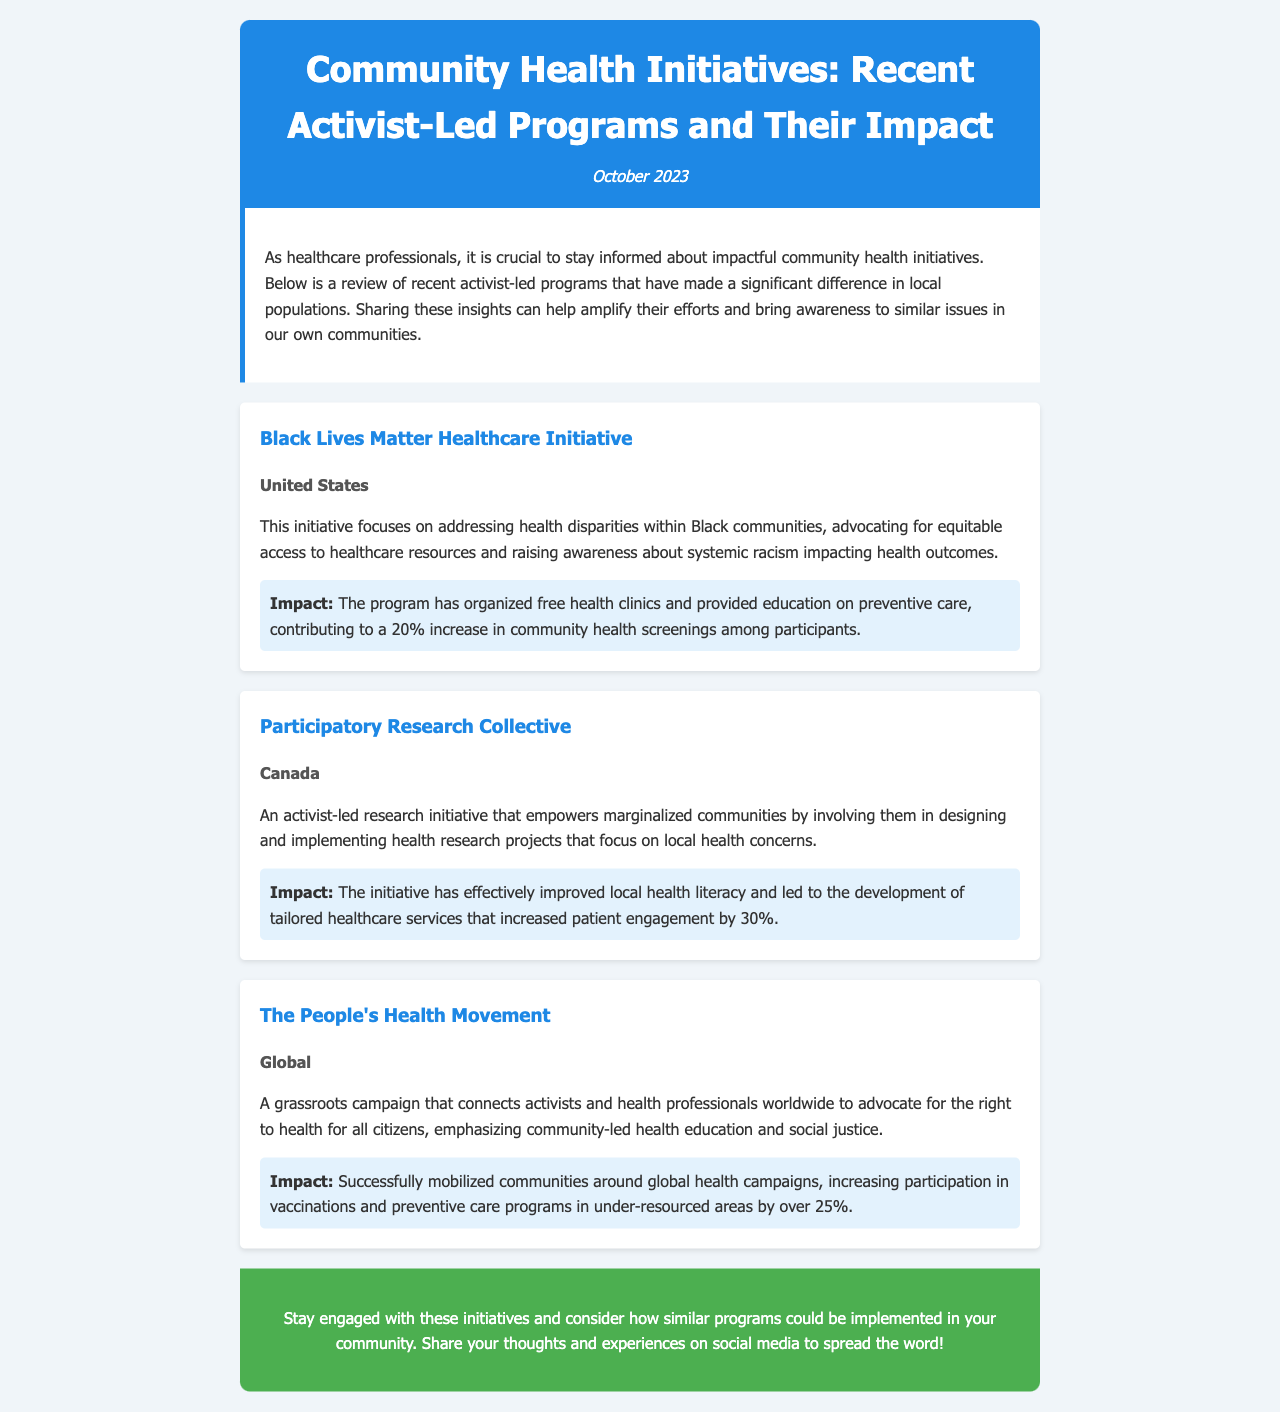what is the title of the newsletter? The title is prominently displayed in the header section of the document.
Answer: Community Health Initiatives: Recent Activist-Led Programs and Their Impact what is the impact percentage of the Black Lives Matter Healthcare Initiative on community health screenings? The initiative's impact on community health screenings is explicitly stated under the impact section.
Answer: 20% which country is the Participatory Research Collective based in? The location of the initiative is mentioned in the program information section.
Answer: Canada what type of movement is The People's Health Movement? The type of movement is described in the introduction of the program segment.
Answer: grassroots how much did patient engagement increase by the Participatory Research Collective? This increase is specifically outlined in the impact description of the program.
Answer: 30% what is the common theme addressed by all the initiatives? The overarching theme is implied throughout the descriptions of the programs.
Answer: health disparities when was the newsletter published? The publication date is cited in the header section of the document.
Answer: October 2023 what color is used for the header background? The header section color is detailed in the styling elements of the document.
Answer: blue what is the call to action at the bottom of the newsletter? The last section emphasizes engagement and sharing on social media; the text directly provides a call to action.
Answer: Stay engaged with these initiatives and consider how similar programs could be implemented in your community 